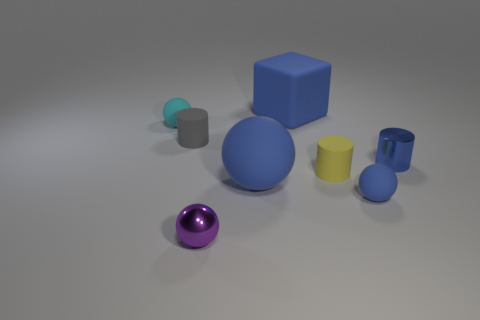Subtract all purple shiny balls. How many balls are left? 3 Add 1 large gray metal cylinders. How many objects exist? 9 Subtract all brown cylinders. How many blue balls are left? 2 Subtract all cubes. How many objects are left? 7 Subtract all gray cylinders. How many cylinders are left? 2 Subtract all cyan balls. Subtract all green cylinders. How many balls are left? 3 Subtract all tiny blue cylinders. Subtract all yellow matte cylinders. How many objects are left? 6 Add 7 tiny blue shiny cylinders. How many tiny blue shiny cylinders are left? 8 Add 7 brown shiny blocks. How many brown shiny blocks exist? 7 Subtract 0 gray spheres. How many objects are left? 8 